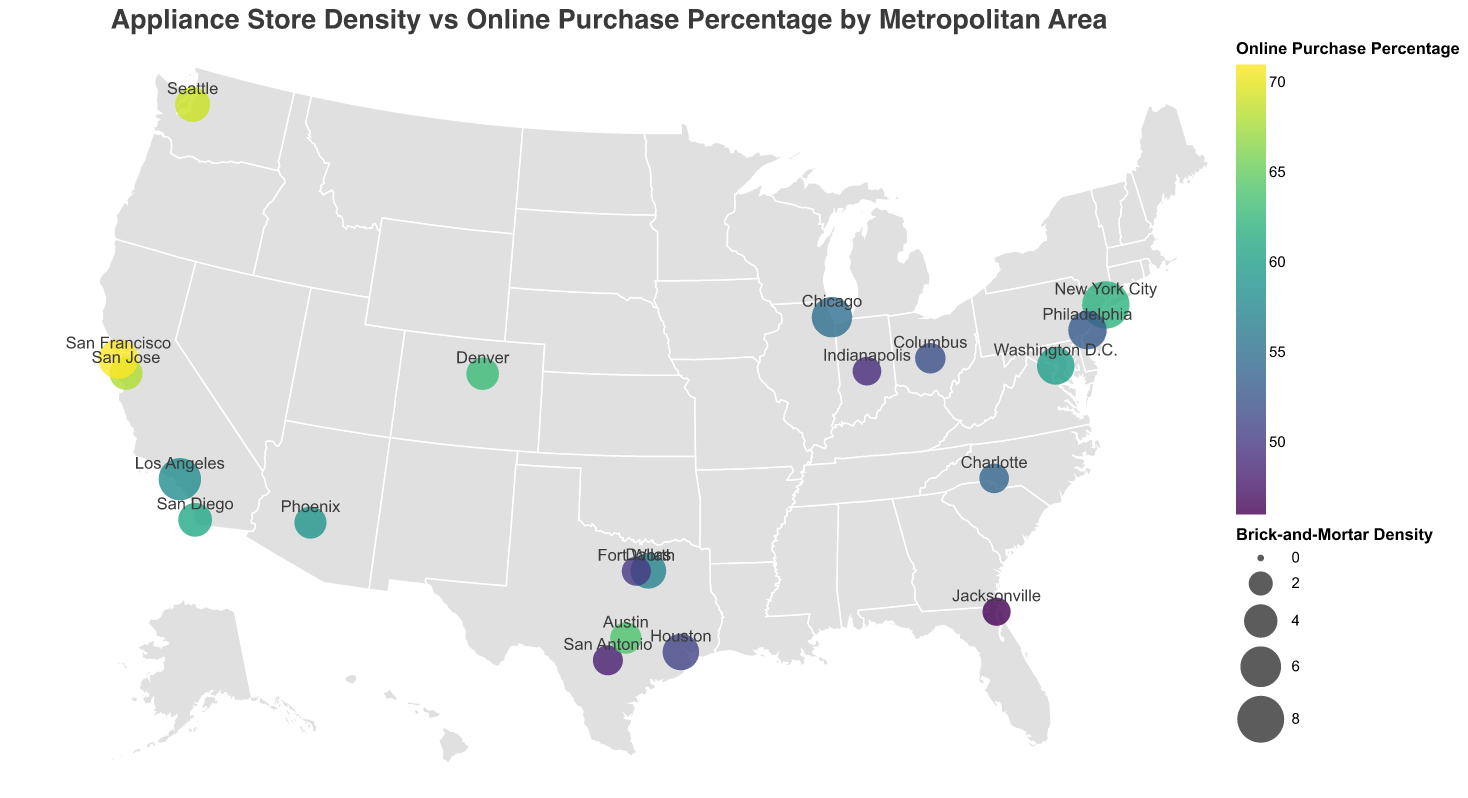What's the title of the figure? The title is displayed at the top of the figure in large font, describing the overall content of the plot.
Answer: Appliance Store Density vs Online Purchase Percentage by Metropolitan Area Which metropolitan area has the highest density of brick-and-mortar appliance stores? The size of the circle represents the brick-and-mortar density. The largest circle corresponds to New York City.
Answer: New York City What color represents the highest percentage of online purchases? The color scale used is "viridis," transitioning from dark to light. The lightest color represents the highest value.
Answer: Light yellowish-green Which metropolitan area has the highest percentage of online purchases? The color intensity indicates the online purchase percentage, and San Francisco is the lightest, suggesting it has the highest percentage.
Answer: San Francisco Compare the brick-and-mortar density of New York City and Los Angeles. New York City has a larger circle indicating a higher density compared to Los Angeles.
Answer: New York City has a higher density What is the average brick-and-mortar density of all listed metropolitan areas? Sum all the densities (8.2 + 6.5 + 5.9 + 4.8 + 3.7 + 5.3 + 3.2 + 4.1 + 4.6 + 3.9 + 3.5 + 2.8 + 5.7 + 3.3 + 3.0 + 2.9 + 3.1 + 4.4 + 3.8 + 5.1) and divide by the total number of areas (20). Average = (89.9 / 20).
Answer: 4.5 Which metropolitan area has both a relatively low brick-and-mortar density and a high online purchase percentage? Look for smaller circles (low density) with lighter colors (high online percentage). San Jose has a low density (3.9) but a high purchase percentage (68).
Answer: San Jose List all metropolitan areas with a brick-and-mortar density below 4.0 and online purchase percentage above 60. Identify the areas with these specific criteria: San Diego (4.1, 61), San Jose (3.9, 68), Austin (3.5, 64), Denver (3.8, 63).
Answer: San Diego, San Jose, Austin, Denver Is there any visible correlation between brick-and-mortar density and online purchase percentage? Observe the size and color of the circles. While many lower-dense areas seem to have higher online percentages (lighter colors), the relationship isn't perfectly linear.
Answer: Loose negative correlation What are the coordinates of Philadelphia on the plot? Philadelphia's coordinates are indicated in the data list: Latitude 39.9526, Longitude -75.1652.
Answer: 39.9526, -75.1652 